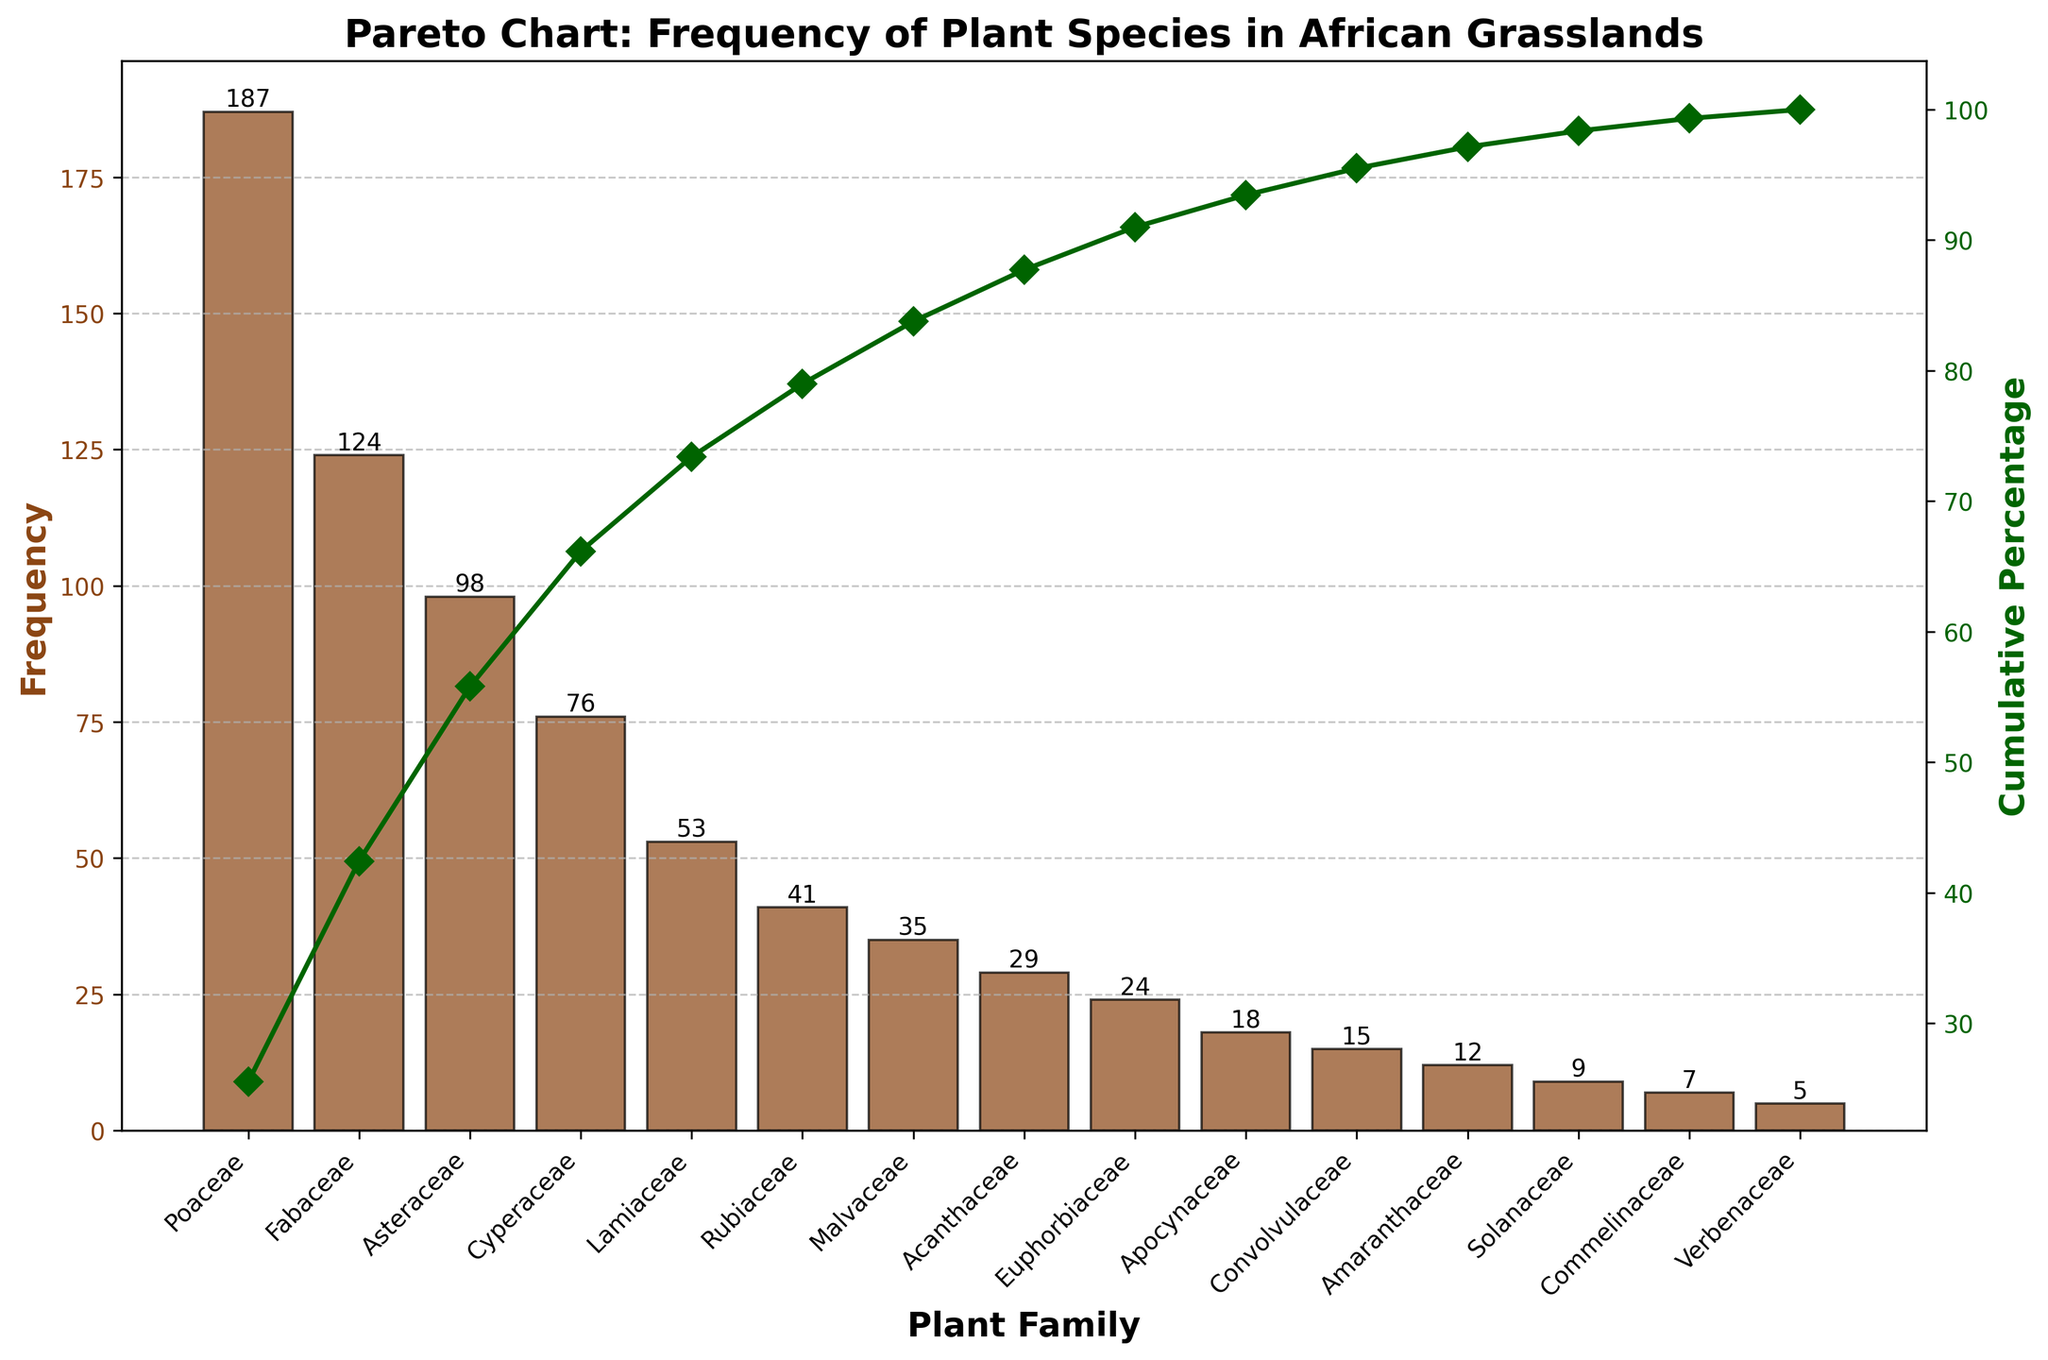What's the title of the figure? The title of the figure is usually found at the top of the plot. It provides a short description of what the figure is about.
Answer: Pareto Chart: Frequency of Plant Species in African Grasslands Which plant family has the highest frequency of collected species? The highest bar on the bar chart indicates the plant family with the highest frequency.
Answer: Poaceae What is the frequency of species collected for the Fabaceae family? The height of the bar corresponding to the Fabaceae family on the x-axis shows the frequency value.
Answer: 124 How much more frequent are Poaceae species compared to Acanthaceae species? Subtract the frequency of Acanthaceae from the frequency of Poaceae to find the difference.
Answer: 158 What is the total cumulative percentage for the top three plant families? The cumulative percentage is the sum of the individual percentages for the top three families: Poaceae, Fabaceae, and Asteraceae. Add their cumulative percentages from the line plot.
Answer: 72.26% Which family marks the point where the cumulative percentage first exceeds 50%? Identify the family on the x-axis where the line representing cumulative percentage first crosses the 50% mark.
Answer: Poaceae Compare the frequencies of Lamiaceae and Cyperaceae families. Which one is higher, and by how much? Compare the height of the bars for Lamiaceae and Cyperaceae. Subtract the frequency of Lamiaceae from Cyperaceae for the difference.
Answer: Cyperaceae is higher by 23 How many plant families are represented in the figure? Count the number of bars or unique family names on the x-axis.
Answer: 15 What is the cumulative percentage for the Malvaceae family? Locate the cumulative percentage value on the line plot corresponding to the position of Malvaceae on the x-axis.
Answer: 87.44% Which family contributes just under 10% to the cumulative frequency and what is the exact percentage it contributes? Find the family whose individual frequency when divided by the total comes just under 10%, verify it with the line plot's cumulative percentage. The exact percentage contributed by this family can be calculated as (Frequency/Total) * 100.
Answer: Asteraceae, 9.67% 